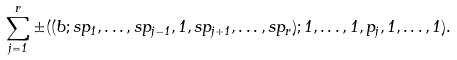Convert formula to latex. <formula><loc_0><loc_0><loc_500><loc_500>\sum _ { j = 1 } ^ { r } \pm ( ( b ; s p _ { 1 } , \dots , s p _ { j - 1 } , 1 , s p _ { j + 1 } , \dots , s p _ { r } ) ; 1 , \dots , 1 , p _ { j } , 1 , \dots , 1 ) .</formula> 